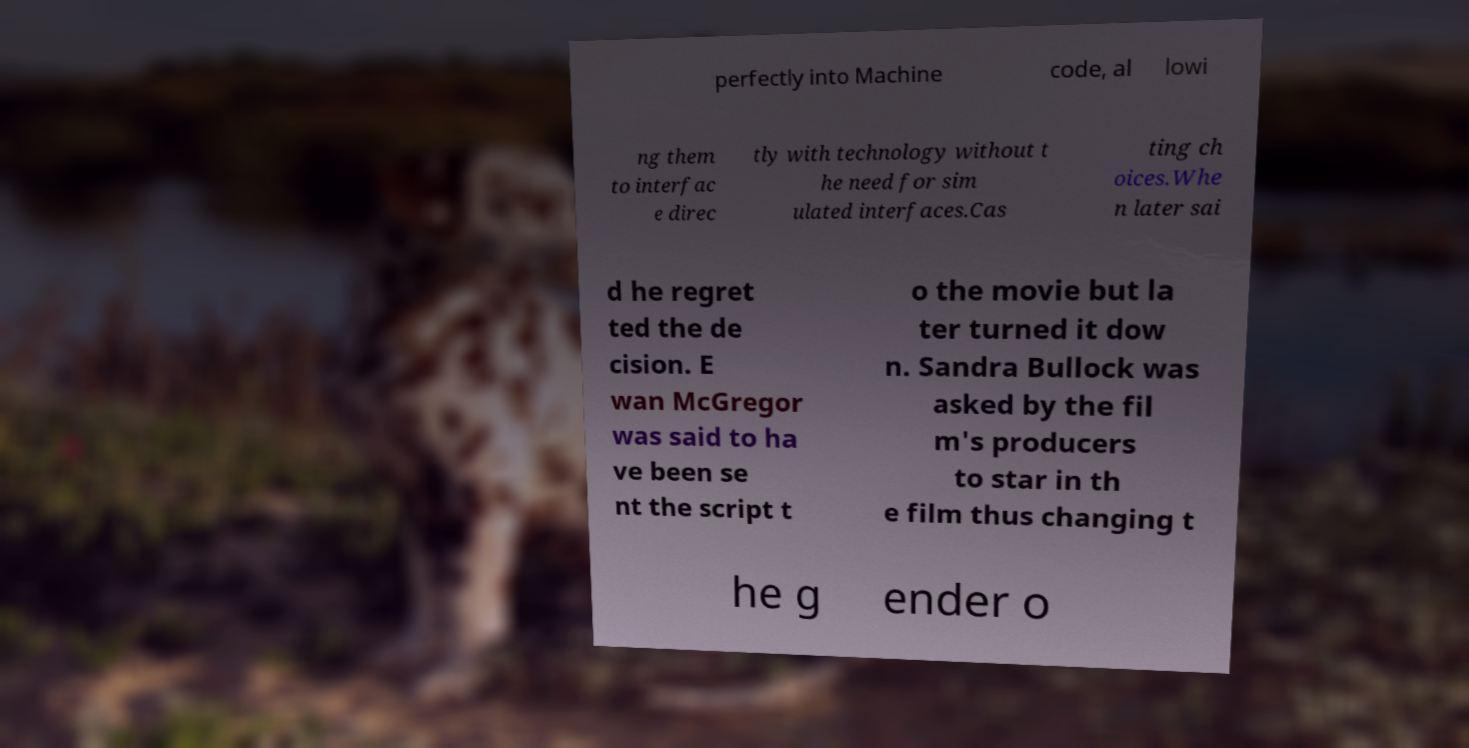For documentation purposes, I need the text within this image transcribed. Could you provide that? perfectly into Machine code, al lowi ng them to interfac e direc tly with technology without t he need for sim ulated interfaces.Cas ting ch oices.Whe n later sai d he regret ted the de cision. E wan McGregor was said to ha ve been se nt the script t o the movie but la ter turned it dow n. Sandra Bullock was asked by the fil m's producers to star in th e film thus changing t he g ender o 